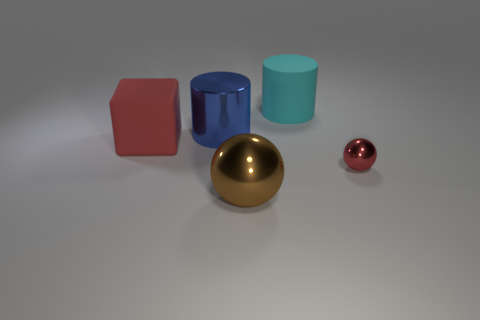What number of metal things are on the right side of the big matte cylinder and to the left of the cyan cylinder?
Provide a succinct answer. 0. There is a big thing in front of the shiny ball behind the metallic sphere left of the small red shiny object; what is its material?
Your response must be concise. Metal. How many other spheres have the same material as the brown sphere?
Keep it short and to the point. 1. There is a tiny shiny object that is the same color as the rubber block; what shape is it?
Your answer should be very brief. Sphere. There is a red rubber object that is the same size as the brown thing; what shape is it?
Offer a very short reply. Cube. There is a large thing that is the same color as the tiny shiny object; what is its material?
Offer a terse response. Rubber. There is a large brown sphere; are there any big metallic things right of it?
Your response must be concise. No. Are there any purple things of the same shape as the blue object?
Offer a very short reply. No. Do the red thing to the right of the brown thing and the brown metal thing that is in front of the shiny cylinder have the same shape?
Offer a terse response. Yes. Are there any blue cubes of the same size as the metallic cylinder?
Provide a short and direct response. No. 